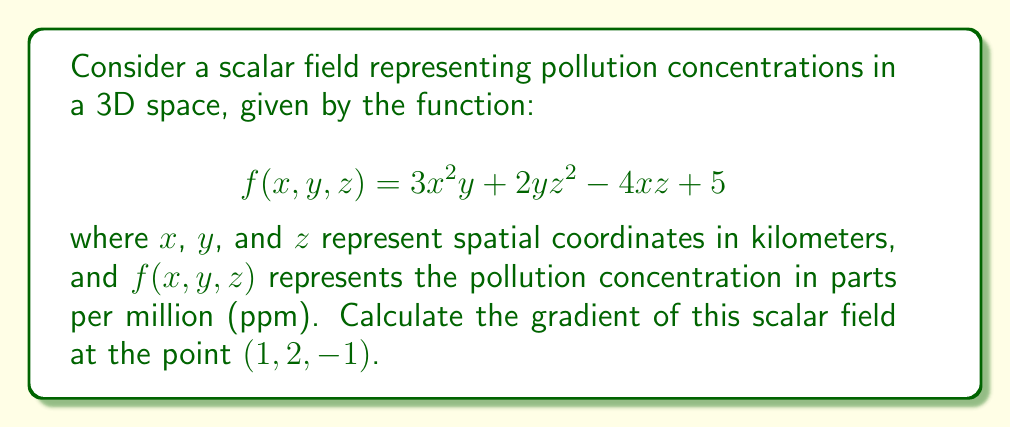Provide a solution to this math problem. To solve this problem, we need to follow these steps:

1) The gradient of a scalar field $f(x,y,z)$ is defined as:

   $$\nabla f = \left(\frac{\partial f}{\partial x}, \frac{\partial f}{\partial y}, \frac{\partial f}{\partial z}\right)$$

2) We need to calculate each partial derivative:

   a) $\frac{\partial f}{\partial x} = 6xy - 4z$
   
   b) $\frac{\partial f}{\partial y} = 3x^2 + 2z^2$
   
   c) $\frac{\partial f}{\partial z} = 4yz - 4x$

3) Now, we substitute the point $(1, 2, -1)$ into each partial derivative:

   a) $\frac{\partial f}{\partial x}|_{(1,2,-1)} = 6(1)(2) - 4(-1) = 12 + 4 = 16$
   
   b) $\frac{\partial f}{\partial y}|_{(1,2,-1)} = 3(1)^2 + 2(-1)^2 = 3 + 2 = 5$
   
   c) $\frac{\partial f}{\partial z}|_{(1,2,-1)} = 4(2)(-1) - 4(1) = -8 - 4 = -12$

4) The gradient at the point $(1, 2, -1)$ is the vector of these partial derivatives:

   $$\nabla f|_{(1,2,-1)} = (16, 5, -12)$$

This gradient vector indicates the direction of steepest increase in pollution concentration at the given point, and its magnitude represents the rate of change in that direction.
Answer: $$\nabla f|_{(1,2,-1)} = (16, 5, -12)$$ ppm/km 